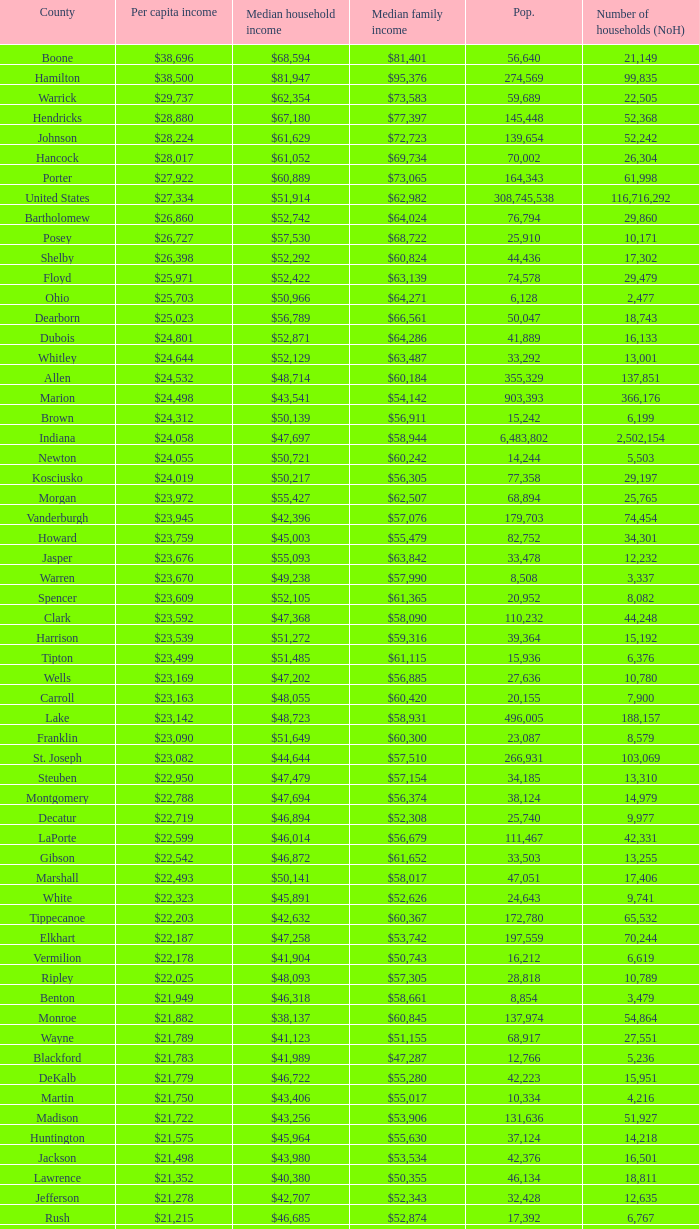What County has a Median household income of $46,872? Gibson. Help me parse the entirety of this table. {'header': ['County', 'Per capita income', 'Median household income', 'Median family income', 'Pop.', 'Number of households (NoH)'], 'rows': [['Boone', '$38,696', '$68,594', '$81,401', '56,640', '21,149'], ['Hamilton', '$38,500', '$81,947', '$95,376', '274,569', '99,835'], ['Warrick', '$29,737', '$62,354', '$73,583', '59,689', '22,505'], ['Hendricks', '$28,880', '$67,180', '$77,397', '145,448', '52,368'], ['Johnson', '$28,224', '$61,629', '$72,723', '139,654', '52,242'], ['Hancock', '$28,017', '$61,052', '$69,734', '70,002', '26,304'], ['Porter', '$27,922', '$60,889', '$73,065', '164,343', '61,998'], ['United States', '$27,334', '$51,914', '$62,982', '308,745,538', '116,716,292'], ['Bartholomew', '$26,860', '$52,742', '$64,024', '76,794', '29,860'], ['Posey', '$26,727', '$57,530', '$68,722', '25,910', '10,171'], ['Shelby', '$26,398', '$52,292', '$60,824', '44,436', '17,302'], ['Floyd', '$25,971', '$52,422', '$63,139', '74,578', '29,479'], ['Ohio', '$25,703', '$50,966', '$64,271', '6,128', '2,477'], ['Dearborn', '$25,023', '$56,789', '$66,561', '50,047', '18,743'], ['Dubois', '$24,801', '$52,871', '$64,286', '41,889', '16,133'], ['Whitley', '$24,644', '$52,129', '$63,487', '33,292', '13,001'], ['Allen', '$24,532', '$48,714', '$60,184', '355,329', '137,851'], ['Marion', '$24,498', '$43,541', '$54,142', '903,393', '366,176'], ['Brown', '$24,312', '$50,139', '$56,911', '15,242', '6,199'], ['Indiana', '$24,058', '$47,697', '$58,944', '6,483,802', '2,502,154'], ['Newton', '$24,055', '$50,721', '$60,242', '14,244', '5,503'], ['Kosciusko', '$24,019', '$50,217', '$56,305', '77,358', '29,197'], ['Morgan', '$23,972', '$55,427', '$62,507', '68,894', '25,765'], ['Vanderburgh', '$23,945', '$42,396', '$57,076', '179,703', '74,454'], ['Howard', '$23,759', '$45,003', '$55,479', '82,752', '34,301'], ['Jasper', '$23,676', '$55,093', '$63,842', '33,478', '12,232'], ['Warren', '$23,670', '$49,238', '$57,990', '8,508', '3,337'], ['Spencer', '$23,609', '$52,105', '$61,365', '20,952', '8,082'], ['Clark', '$23,592', '$47,368', '$58,090', '110,232', '44,248'], ['Harrison', '$23,539', '$51,272', '$59,316', '39,364', '15,192'], ['Tipton', '$23,499', '$51,485', '$61,115', '15,936', '6,376'], ['Wells', '$23,169', '$47,202', '$56,885', '27,636', '10,780'], ['Carroll', '$23,163', '$48,055', '$60,420', '20,155', '7,900'], ['Lake', '$23,142', '$48,723', '$58,931', '496,005', '188,157'], ['Franklin', '$23,090', '$51,649', '$60,300', '23,087', '8,579'], ['St. Joseph', '$23,082', '$44,644', '$57,510', '266,931', '103,069'], ['Steuben', '$22,950', '$47,479', '$57,154', '34,185', '13,310'], ['Montgomery', '$22,788', '$47,694', '$56,374', '38,124', '14,979'], ['Decatur', '$22,719', '$46,894', '$52,308', '25,740', '9,977'], ['LaPorte', '$22,599', '$46,014', '$56,679', '111,467', '42,331'], ['Gibson', '$22,542', '$46,872', '$61,652', '33,503', '13,255'], ['Marshall', '$22,493', '$50,141', '$58,017', '47,051', '17,406'], ['White', '$22,323', '$45,891', '$52,626', '24,643', '9,741'], ['Tippecanoe', '$22,203', '$42,632', '$60,367', '172,780', '65,532'], ['Elkhart', '$22,187', '$47,258', '$53,742', '197,559', '70,244'], ['Vermilion', '$22,178', '$41,904', '$50,743', '16,212', '6,619'], ['Ripley', '$22,025', '$48,093', '$57,305', '28,818', '10,789'], ['Benton', '$21,949', '$46,318', '$58,661', '8,854', '3,479'], ['Monroe', '$21,882', '$38,137', '$60,845', '137,974', '54,864'], ['Wayne', '$21,789', '$41,123', '$51,155', '68,917', '27,551'], ['Blackford', '$21,783', '$41,989', '$47,287', '12,766', '5,236'], ['DeKalb', '$21,779', '$46,722', '$55,280', '42,223', '15,951'], ['Martin', '$21,750', '$43,406', '$55,017', '10,334', '4,216'], ['Madison', '$21,722', '$43,256', '$53,906', '131,636', '51,927'], ['Huntington', '$21,575', '$45,964', '$55,630', '37,124', '14,218'], ['Jackson', '$21,498', '$43,980', '$53,534', '42,376', '16,501'], ['Lawrence', '$21,352', '$40,380', '$50,355', '46,134', '18,811'], ['Jefferson', '$21,278', '$42,707', '$52,343', '32,428', '12,635'], ['Rush', '$21,215', '$46,685', '$52,874', '17,392', '6,767'], ['Switzerland', '$21,214', '$44,503', '$51,769', '10,613', '4,034'], ['Clinton', '$21,131', '$48,416', '$57,445', '33,224', '12,105'], ['Fulton', '$21,119', '$40,372', '$47,972', '20,836', '8,237'], ['Fountain', '$20,949', '$42,817', '$51,696', '17,240', '6,935'], ['Perry', '$20,806', '$45,108', '$55,497', '19,338', '7,476'], ['Greene', '$20,676', '$41,103', '$50,740', '33,165', '13,487'], ['Owen', '$20,581', '$44,285', '$52,343', '21,575', '8,486'], ['Clay', '$20,569', '$44,666', '$52,907', '26,890', '10,447'], ['Cass', '$20,562', '$42,587', '$49,873', '38,966', '14,858'], ['Pulaski', '$20,491', '$44,016', '$50,903', '13,402', '5,282'], ['Wabash', '$20,475', '$43,157', '$52,758', '32,888', '12,777'], ['Putnam', '$20,441', '$48,992', '$59,354', '37,963', '12,917'], ['Delaware', '$20,405', '$38,066', '$51,394', '117,671', '46,516'], ['Vigo', '$20,398', '$38,508', '$50,413', '107,848', '41,361'], ['Knox', '$20,381', '$39,523', '$51,534', '38,440', '15,249'], ['Daviess', '$20,254', '$44,592', '$53,769', '31,648', '11,329'], ['Sullivan', '$20,093', '$44,184', '$52,558', '21,475', '7,823'], ['Pike', '$20,005', '$41,222', '$49,423', '12,845', '5,186'], ['Henry', '$19,879', '$41,087', '$52,701', '49,462', '19,077'], ['Grant', '$19,792', '$38,985', '$49,860', '70,061', '27,245'], ['Noble', '$19,783', '$45,818', '$53,959', '47,536', '17,355'], ['Randolph', '$19,552', '$40,990', '$45,543', '26,171', '10,451'], ['Parke', '$19,494', '$40,512', '$51,581', '17,339', '6,222'], ['Scott', '$19,414', '$39,588', '$46,775', '24,181', '9,397'], ['Washington', '$19,278', '$39,722', '$45,500', '28,262', '10,850'], ['Union', '$19,243', '$43,257', '$49,815', '7,516', '2,938'], ['Orange', '$19,119', '$37,120', '$45,874', '19,840', '7,872'], ['Adams', '$19,089', '$43,317', '$53,106', '34,387', '12,011'], ['Jay', '$18,946', '$39,886', '$47,926', '21,253', '8,133'], ['Fayette', '$18,928', '$37,038', '$46,601', '24,277', '9,719'], ['Miami', '$18,854', '$39,485', '$49,282', '36,903', '13,456'], ['Jennings', '$18,636', '$43,755', '$48,470', '28,525', '10,680'], ['Crawford', '$18,598', '$37,988', '$46,073', '10,713', '4,303'], ['LaGrange', '$18,388', '$47,792', '$53,793', '37,128', '11,598'], ['Starke', '$17,991', '$37,480', '$44,044', '23,363', '9,038']]} 